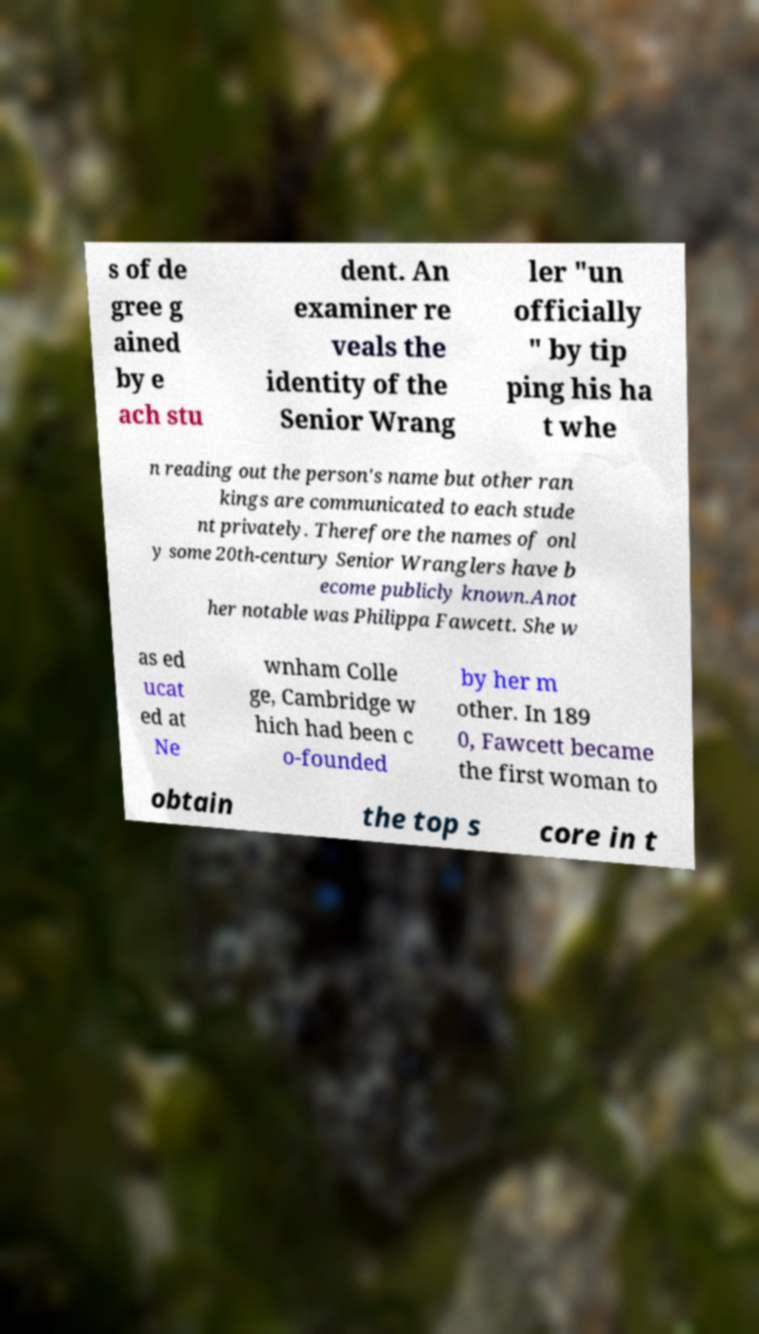Please read and relay the text visible in this image. What does it say? s of de gree g ained by e ach stu dent. An examiner re veals the identity of the Senior Wrang ler "un officially " by tip ping his ha t whe n reading out the person's name but other ran kings are communicated to each stude nt privately. Therefore the names of onl y some 20th-century Senior Wranglers have b ecome publicly known.Anot her notable was Philippa Fawcett. She w as ed ucat ed at Ne wnham Colle ge, Cambridge w hich had been c o-founded by her m other. In 189 0, Fawcett became the first woman to obtain the top s core in t 